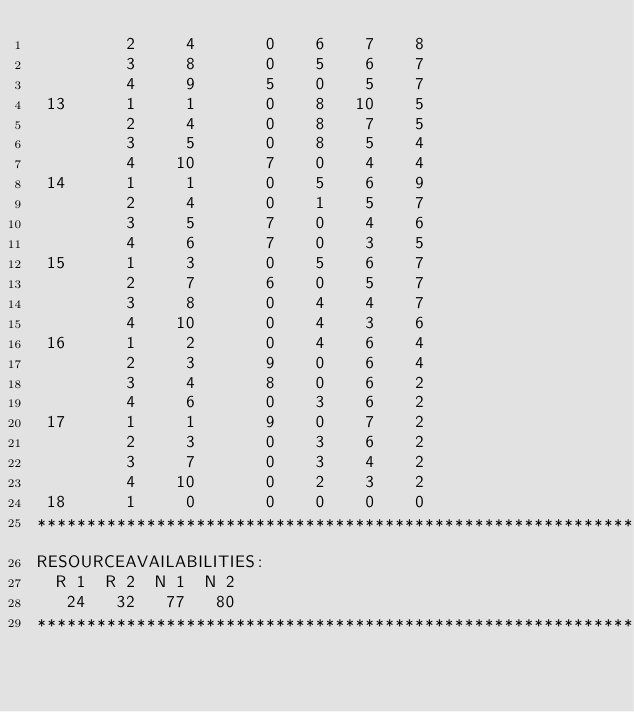<code> <loc_0><loc_0><loc_500><loc_500><_ObjectiveC_>         2     4       0    6    7    8
         3     8       0    5    6    7
         4     9       5    0    5    7
 13      1     1       0    8   10    5
         2     4       0    8    7    5
         3     5       0    8    5    4
         4    10       7    0    4    4
 14      1     1       0    5    6    9
         2     4       0    1    5    7
         3     5       7    0    4    6
         4     6       7    0    3    5
 15      1     3       0    5    6    7
         2     7       6    0    5    7
         3     8       0    4    4    7
         4    10       0    4    3    6
 16      1     2       0    4    6    4
         2     3       9    0    6    4
         3     4       8    0    6    2
         4     6       0    3    6    2
 17      1     1       9    0    7    2
         2     3       0    3    6    2
         3     7       0    3    4    2
         4    10       0    2    3    2
 18      1     0       0    0    0    0
************************************************************************
RESOURCEAVAILABILITIES:
  R 1  R 2  N 1  N 2
   24   32   77   80
************************************************************************
</code> 